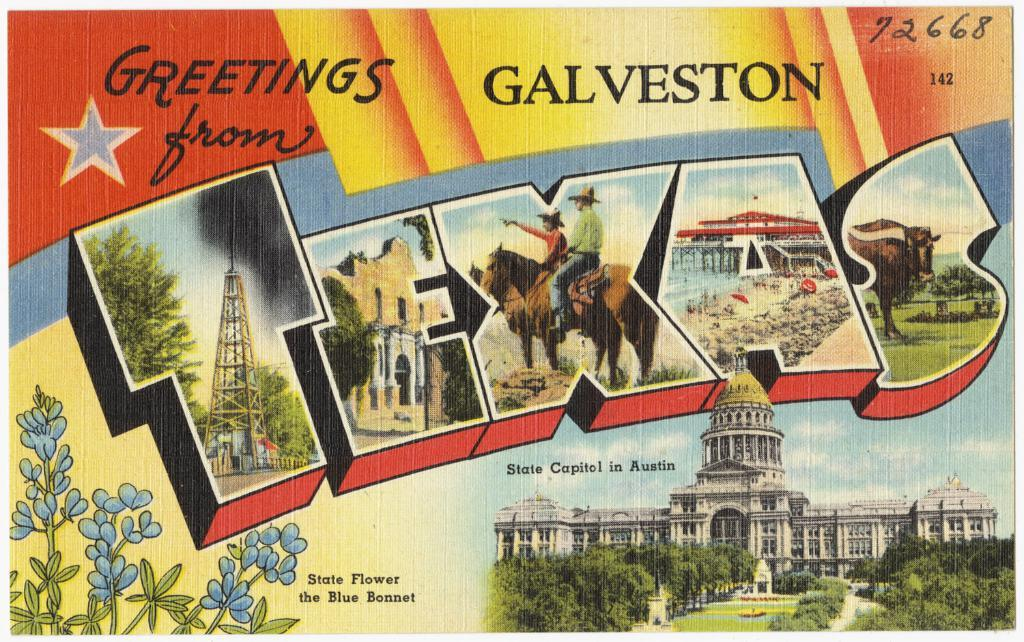<image>
Relay a brief, clear account of the picture shown. A post card that says Greetings from Texas. 